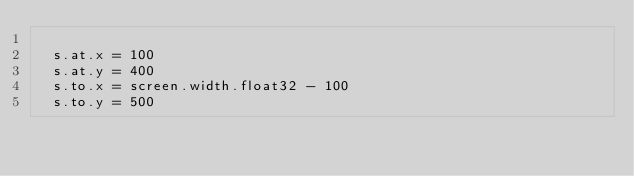Convert code to text. <code><loc_0><loc_0><loc_500><loc_500><_Nim_>
  s.at.x = 100
  s.at.y = 400
  s.to.x = screen.width.float32 - 100
  s.to.y = 500
</code> 